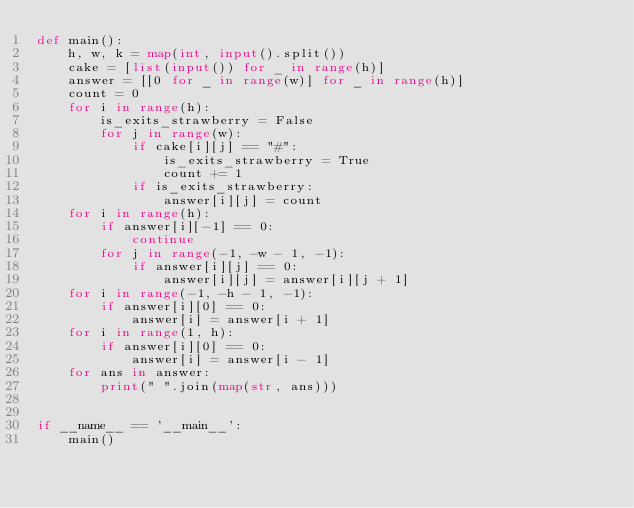<code> <loc_0><loc_0><loc_500><loc_500><_Python_>def main():
    h, w, k = map(int, input().split())
    cake = [list(input()) for _ in range(h)]
    answer = [[0 for _ in range(w)] for _ in range(h)]
    count = 0
    for i in range(h):
        is_exits_strawberry = False
        for j in range(w):
            if cake[i][j] == "#":
                is_exits_strawberry = True
                count += 1
            if is_exits_strawberry:
                answer[i][j] = count
    for i in range(h):
        if answer[i][-1] == 0:
            continue
        for j in range(-1, -w - 1, -1):
            if answer[i][j] == 0:
                answer[i][j] = answer[i][j + 1]
    for i in range(-1, -h - 1, -1):
        if answer[i][0] == 0:
            answer[i] = answer[i + 1]
    for i in range(1, h):
        if answer[i][0] == 0:
            answer[i] = answer[i - 1]
    for ans in answer:
        print(" ".join(map(str, ans)))


if __name__ == '__main__':
    main()

</code> 